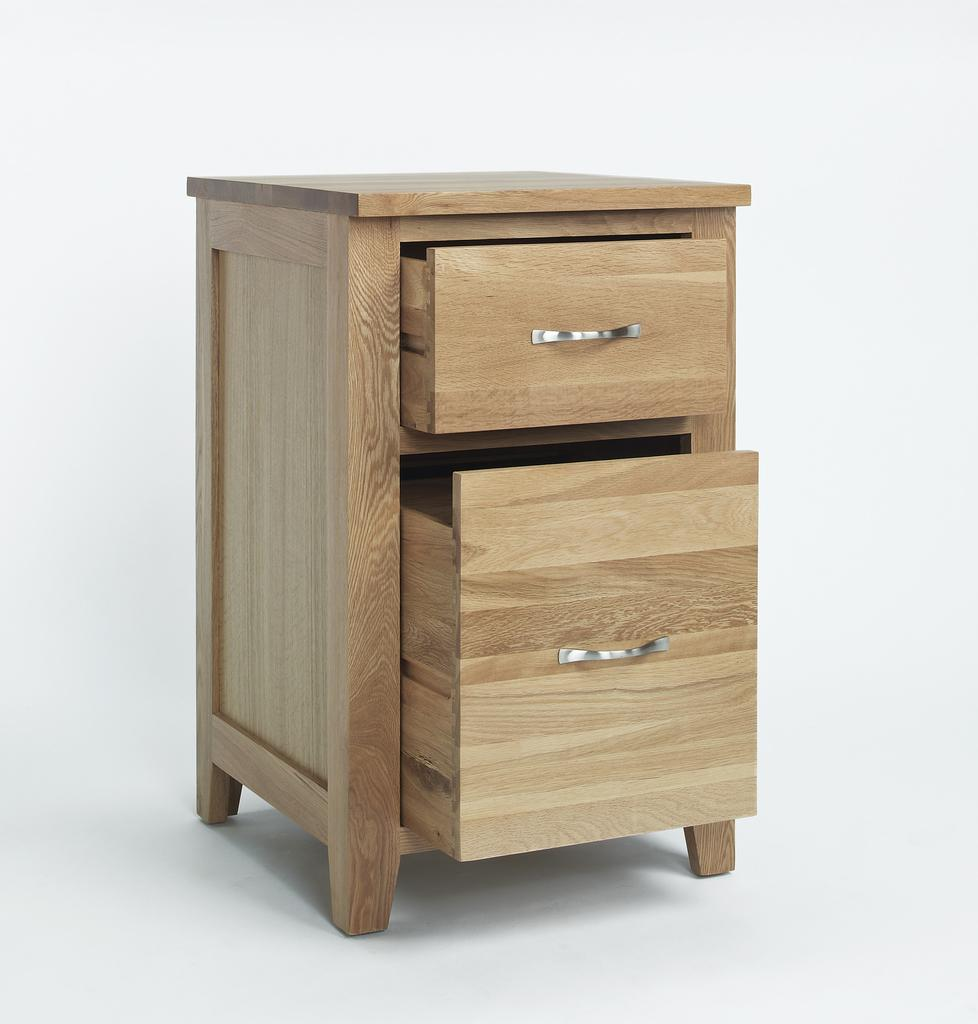What type of furniture is present in the image? There is a table in the image. What are the drawers on the table used for? The table has two drawers, which can be used for storage. What material is the table made of? The table is made of wood. What are the handles of the drawers made of? The handles of the drawers are made of metal. How many corners does the table have? The table has four corners. What is the tax rate for the table in the image? There is no information about tax rates in the image, as it is a picture of a table and not a financial document. 